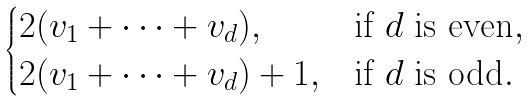<formula> <loc_0><loc_0><loc_500><loc_500>\begin{cases} 2 ( v _ { 1 } + \dots + v _ { d } ) , & \text {if $d$ is even} , \\ 2 ( v _ { 1 } + \dots + v _ { d } ) + 1 , & \text {if $d$ is odd} . \\ \end{cases}</formula> 